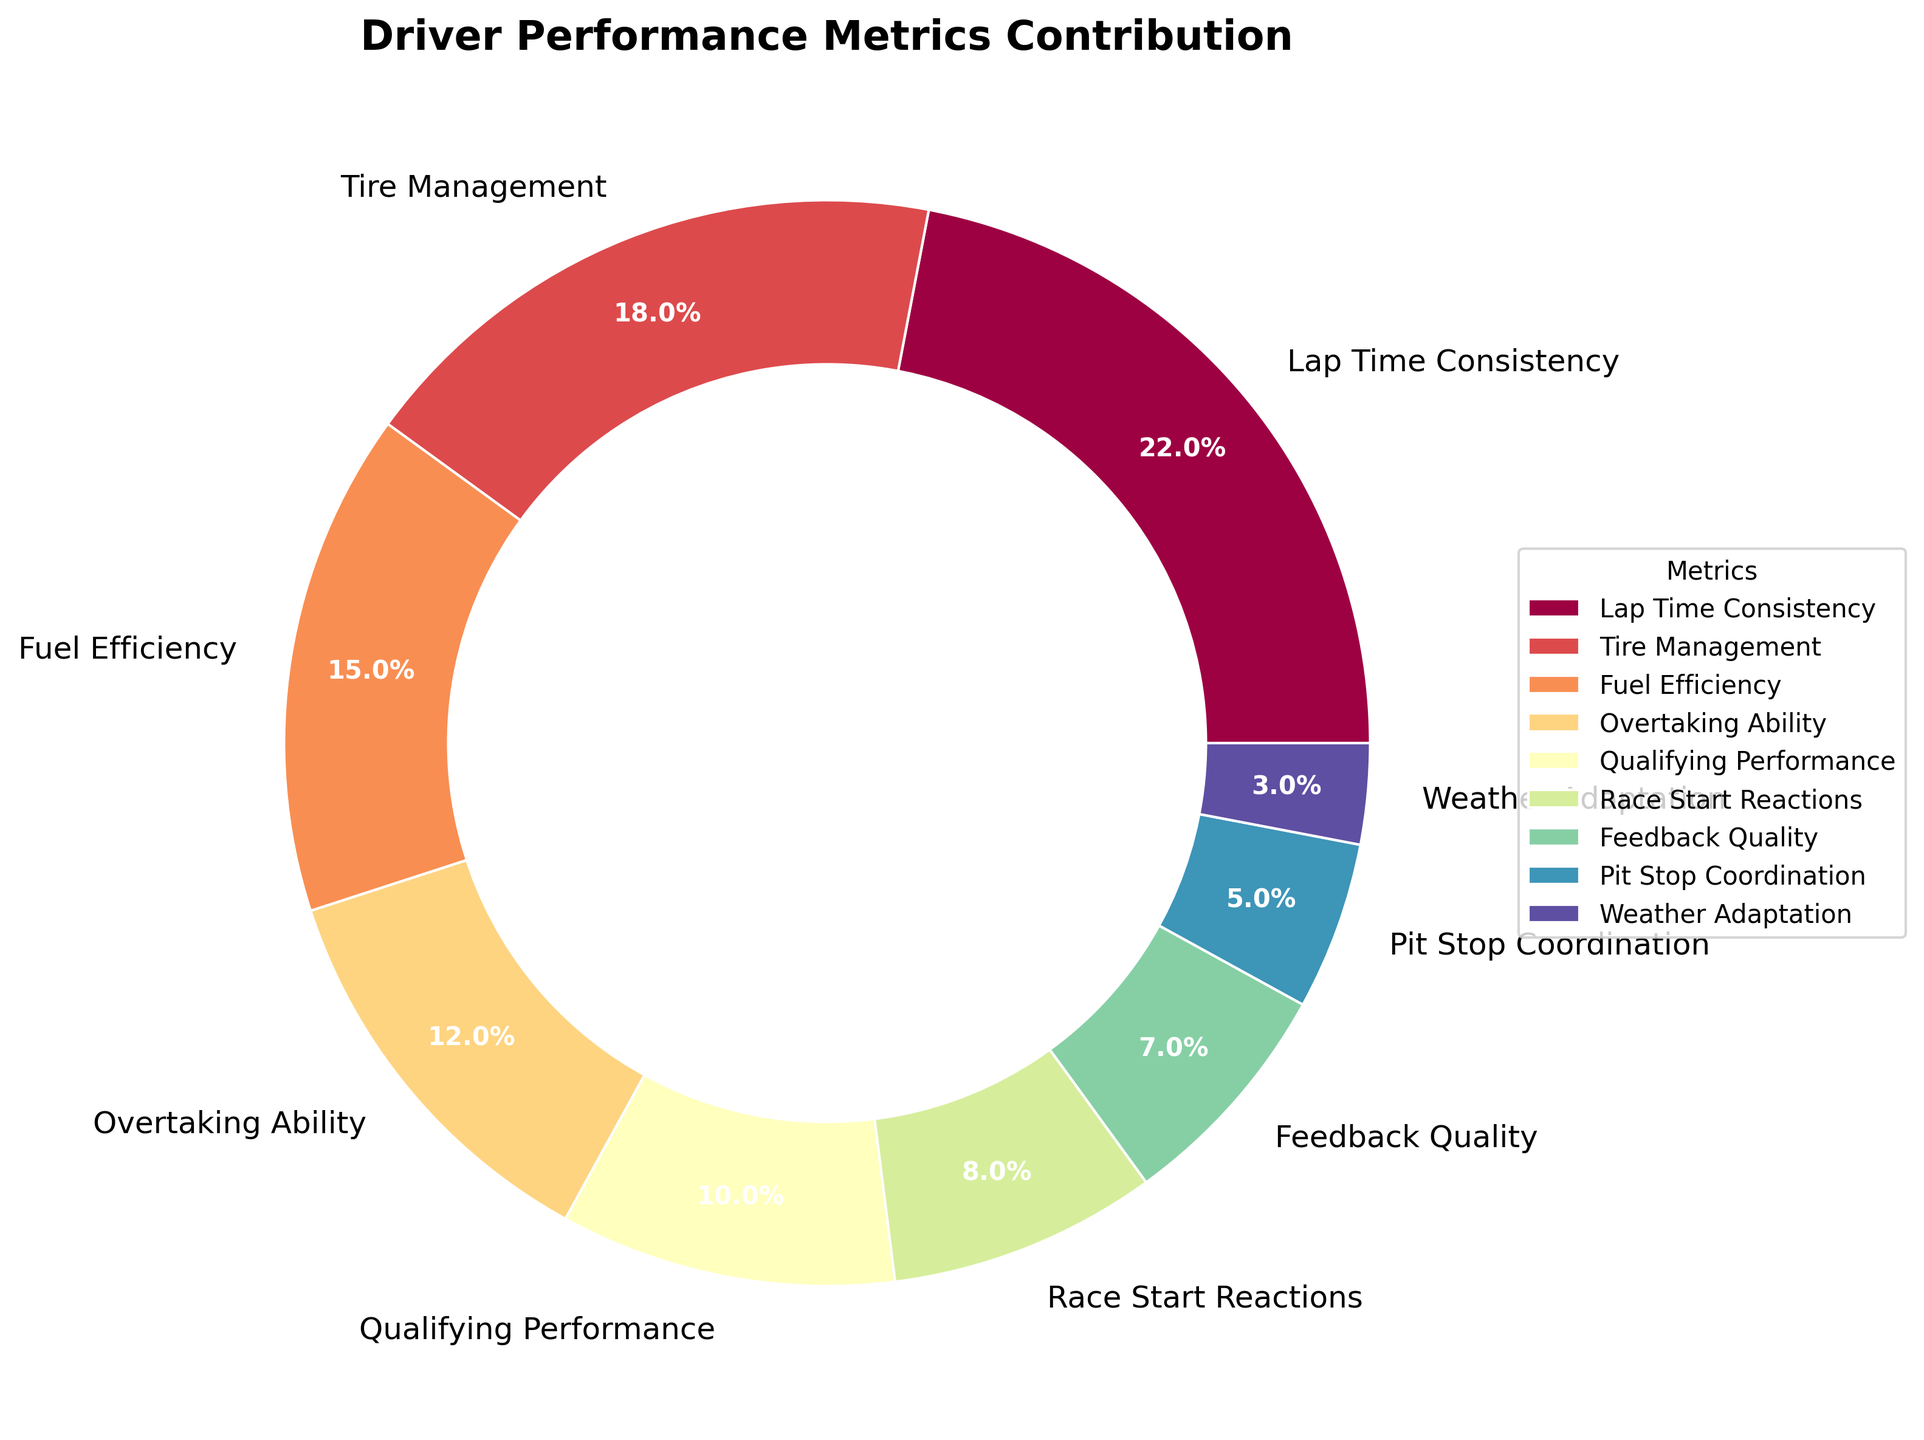What's the combined contribution percentage of 'Fuel Efficiency,' 'Overtaking Ability,' and 'Feedback Quality'? First, find the individual contributions: Fuel Efficiency (15%), Overtaking Ability (12%), and Feedback Quality (7%). Sum these values: 15 + 12 + 7 = 34. So, the combined contribution is 34%.
Answer: 34% Which metric has the smallest contribution, and what is its percentage? Identify the metric with the smallest percentage contribution from the chart. 'Weather Adaptation' has the smallest contribution of 3%.
Answer: Weather Adaptation, 3% Which metric contributes more to the overall team success: 'Lap Time Consistency' or 'Tire Management'? Compare the contribution percentages of 'Lap Time Consistency' (22%) and 'Tire Management' (18%). 'Lap Time Consistency' has a higher contribution.
Answer: Lap Time Consistency Are the contributions of 'Race Start Reactions' and 'Qualifying Performance' combined greater than 'Lap Time Consistency'? Find the individual values: Race Start Reactions (8%) and Qualifying Performance (10%). Add them: 8 + 10 = 18. Compare this sum (18%) with 'Lap Time Consistency' (22%). 18% is less than 22%.
Answer: No List the metrics that contribute less than 10% to the overall team success. Identify all metrics with contributions below 10%: Race Start Reactions (8%), Feedback Quality (7%), Pit Stop Coordination (5%), Weather Adaptation (3%).
Answer: Race Start Reactions, Feedback Quality, Pit Stop Coordination, Weather Adaptation What is the difference in the contribution percentages between 'Tire Management' and 'Overtaking Ability'? Find the contributions: Tire Management (18%) and Overtaking Ability (12%). Calculate the difference: 18 - 12 = 6.
Answer: 6% Rank the top three metrics in terms of contribution to overall team success. List the metrics in descending order of their contribution percentages: Lap Time Consistency (22%), Tire Management (18%), Fuel Efficiency (15%).
Answer: Lap Time Consistency, Tire Management, Fuel Efficiency What is the average contribution of 'Race Start Reactions,' 'Pit Stop Coordination,' and 'Weather Adaptation'? Find the contributions: Race Start Reactions (8%), Pit Stop Coordination (5%), Weather Adaptation (3%). Sum these values: 8 + 5 + 3 = 16. Divide by the number of metrics (3): 16 / 3 ≈ 5.33.
Answer: 5.33% If the contributions are to be represented in a different color scheme, will the order of contributions change? Changing the color scheme will not affect the numerical values or order of the contributions, only the visual representation will change.
Answer: No 